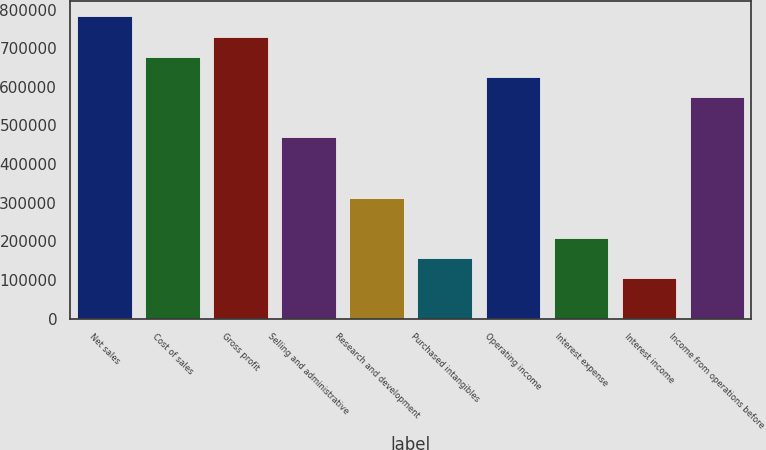Convert chart. <chart><loc_0><loc_0><loc_500><loc_500><bar_chart><fcel>Net sales<fcel>Cost of sales<fcel>Gross profit<fcel>Selling and administrative<fcel>Research and development<fcel>Purchased intangibles<fcel>Operating income<fcel>Interest expense<fcel>Interest income<fcel>Income from operations before<nl><fcel>782129<fcel>677846<fcel>729987<fcel>469278<fcel>312853<fcel>156427<fcel>625704<fcel>208569<fcel>104285<fcel>573562<nl></chart> 